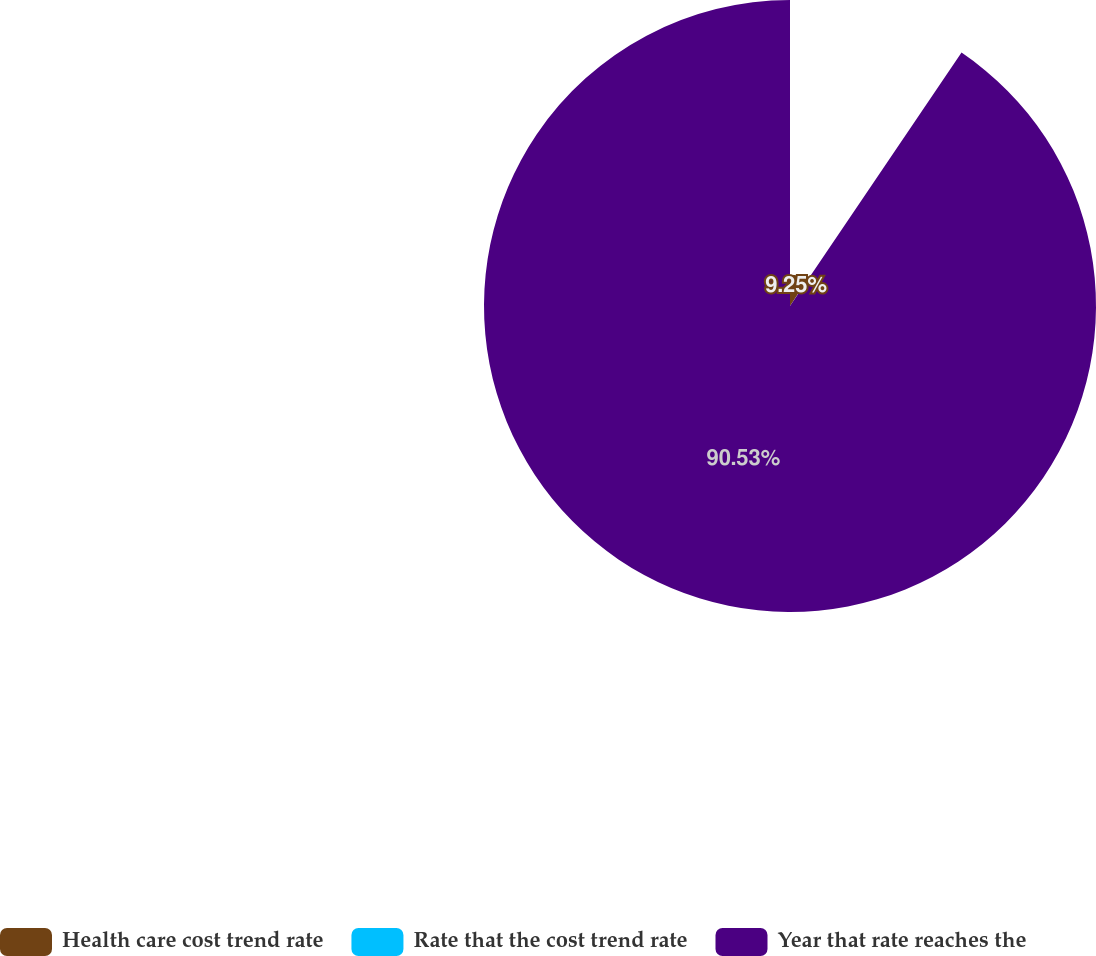<chart> <loc_0><loc_0><loc_500><loc_500><pie_chart><fcel>Health care cost trend rate<fcel>Rate that the cost trend rate<fcel>Year that rate reaches the<nl><fcel>9.25%<fcel>0.22%<fcel>90.52%<nl></chart> 